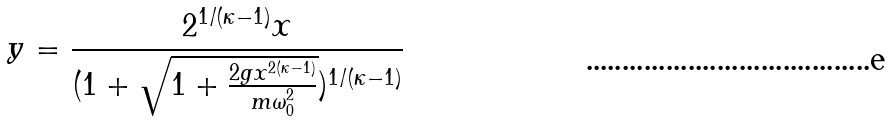Convert formula to latex. <formula><loc_0><loc_0><loc_500><loc_500>y = \frac { 2 ^ { 1 / ( \kappa - 1 ) } x } { ( 1 + \sqrt { 1 + \frac { 2 g x ^ { 2 ( \kappa - 1 ) } } { m \omega _ { 0 } ^ { 2 } } } ) ^ { 1 / ( \kappa - 1 ) } }</formula> 